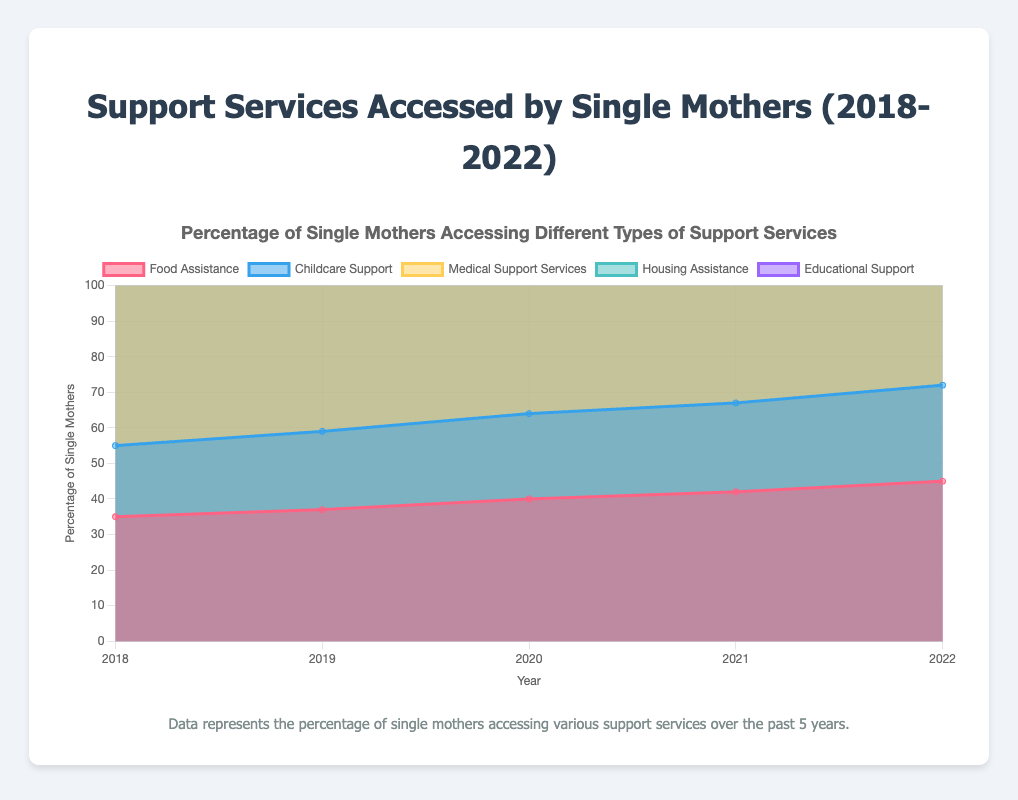What is the title of the figure? The title is typically displayed at the top of the chart. For this chart, it is found in the provided code under the `title` configuration.
Answer: Support Services Accessed by Single Mothers (2018-2022) What was the percentage of single mothers accessing medical support services in 2020? Look for the line labeled "Medical Support Services" and find the data point corresponding to the year 2020.
Answer: 55% Which support service had the highest percentage of access by single mothers in 2022? Compare the end values (year 2022) of all the datasets. The dataset with the highest value represents the most accessed service.
Answer: Medical Support Services (60%) How much did the percentage of single mothers accessing food assistance increase from 2018 to 2022? Subtract the 2018 value for food assistance from the 2022 value for food assistance. This is calculated as 45% - 35%.
Answer: 10% Which service showed the smallest percentage increase from 2018 to 2022? Calculate the percentage increase for each service and identify the smallest. Childcare Support: (27-20)=7, Educational Support: (38-30)=8, Food Assistance: (45-35)=10, Housing Assistance: (35-25)=10, Medical Support Services: (60-50)=10.
Answer: Childcare Support (7%) What is the trend in single mothers accessing housing assistance over the years? Observe the values for housing assistance from 2018 to 2022. The values are 25%, 28%, 30%, 32%, and 35%, respectively.
Answer: Increasing In which year did the percentage of single mothers accessing childcare support reach 25%? Find the data point where the "Childcare Support" line reaches 25% by examining the values over the years.
Answer: 2021 What's the average percentage of single mothers accessing educational support over the 5 years? Add the percentages for each year and divide by the number of years: (30 + 32 + 34 + 36 + 38) / 5 = 34
Answer: 34% By how much did medical support services usage increase from 2019 to 2021? Subtract the 2019 value (52%) from the 2021 value (58%). This gives the increase of 58% - 52%.
Answer: 6% Which support services exhibited the same increase in percentage points from 2018 to 2022? Calculate the percentage point increase for each support service, then compare the increases. Food Assistance: 10 points, Childcare Support: 7 points, Medical Support Services: 10 points, Housing Assistance: 10 points, Educational Support: 8 points. Identify those with equal increases.
Answer: Food Assistance, Medical Support Services, Housing Assistance 